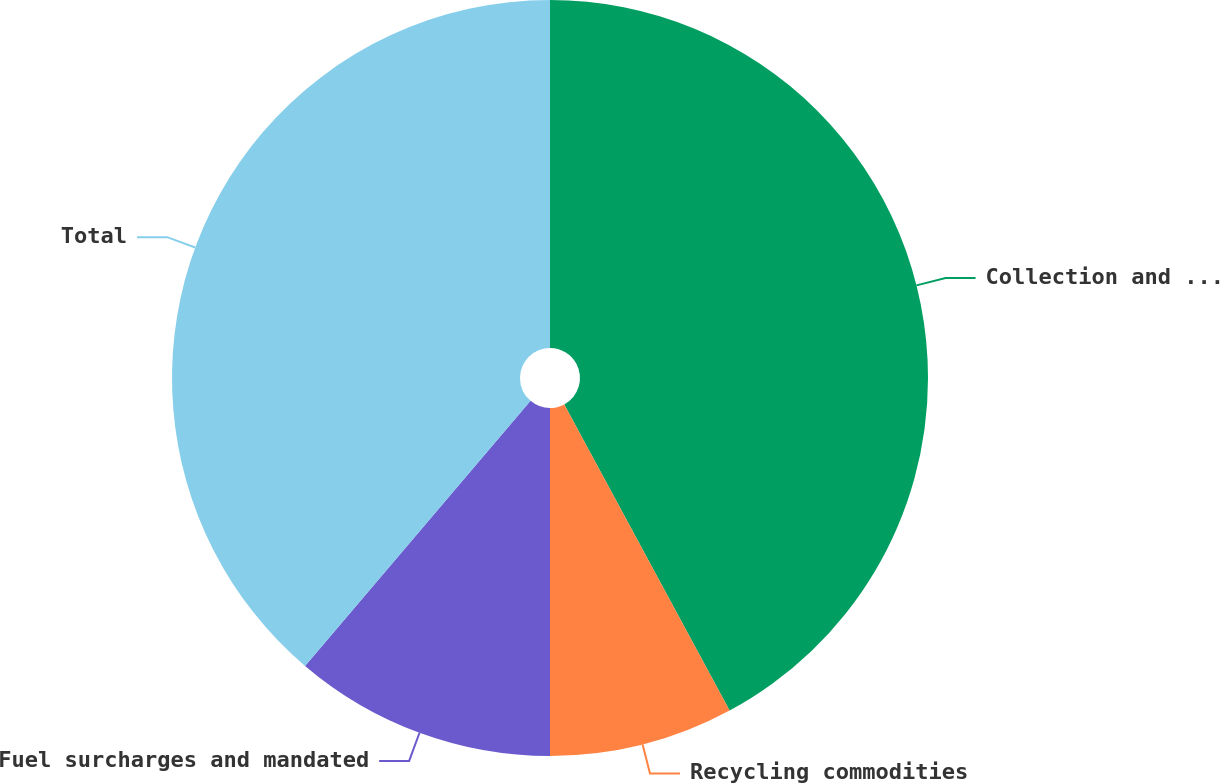<chart> <loc_0><loc_0><loc_500><loc_500><pie_chart><fcel>Collection and disposal<fcel>Recycling commodities<fcel>Fuel surcharges and mandated<fcel>Total<nl><fcel>42.12%<fcel>7.88%<fcel>11.22%<fcel>38.78%<nl></chart> 